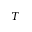<formula> <loc_0><loc_0><loc_500><loc_500>T</formula> 